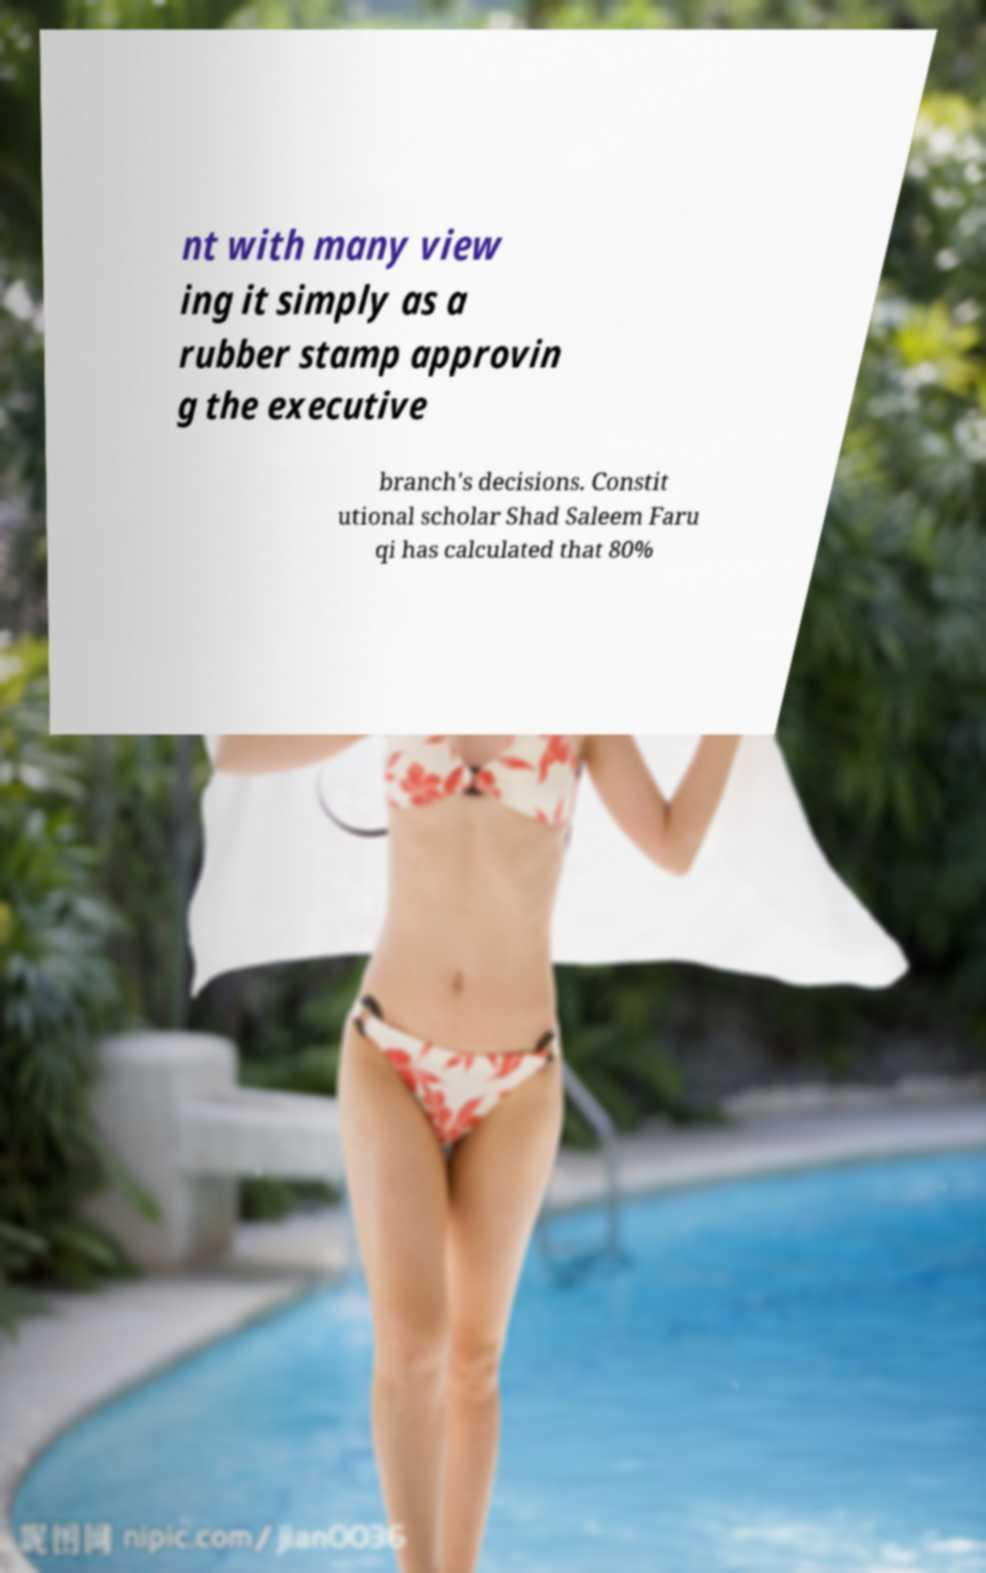Could you extract and type out the text from this image? nt with many view ing it simply as a rubber stamp approvin g the executive branch's decisions. Constit utional scholar Shad Saleem Faru qi has calculated that 80% 